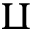<formula> <loc_0><loc_0><loc_500><loc_500>\amalg</formula> 